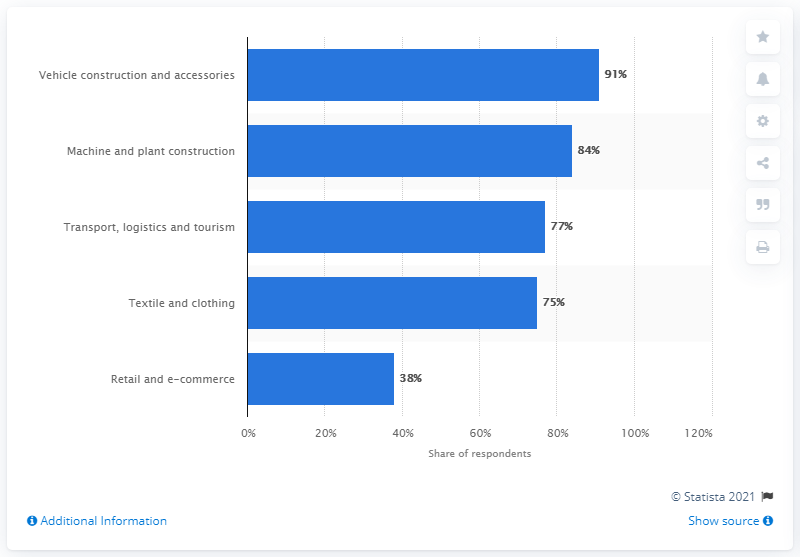Draw attention to some important aspects in this diagram. According to the responses, 91% of the respondents believed that this industry would be negatively impacted by the COVID-19 pandemic. 